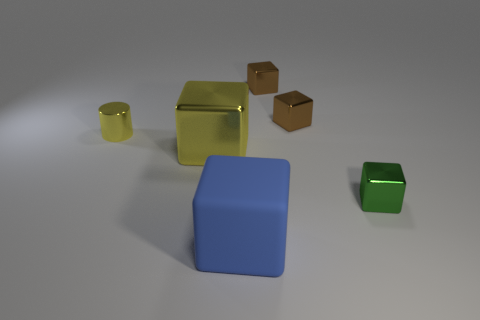Is there any other thing that is made of the same material as the blue cube?
Give a very brief answer. No. What is the size of the metallic cylinder that is the same color as the large metal object?
Your response must be concise. Small. Is there a brown object that has the same material as the green thing?
Provide a succinct answer. Yes. What color is the matte object?
Your response must be concise. Blue. There is a metallic cylinder that is left of the large block on the right side of the large block behind the large blue matte block; what is its size?
Ensure brevity in your answer.  Small. What number of other things are the same shape as the large matte thing?
Provide a short and direct response. 4. There is a shiny object that is in front of the small yellow object and behind the small green block; what is its color?
Your answer should be very brief. Yellow. There is a large object that is behind the blue rubber object; is it the same color as the shiny cylinder?
Your answer should be compact. Yes. How many cubes are matte things or tiny green things?
Your response must be concise. 2. There is a tiny thing in front of the yellow shiny cylinder; what is its shape?
Ensure brevity in your answer.  Cube. 